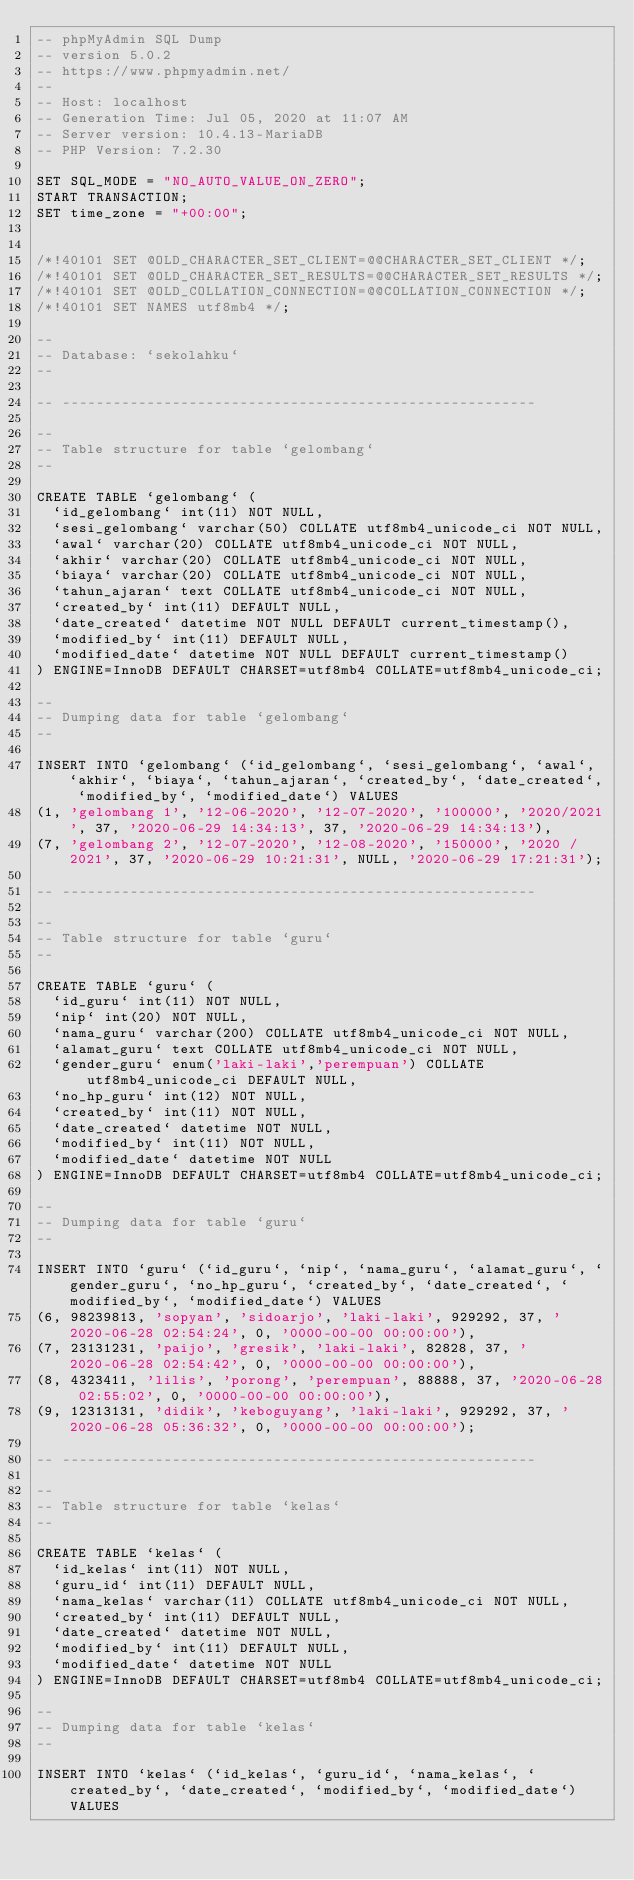Convert code to text. <code><loc_0><loc_0><loc_500><loc_500><_SQL_>-- phpMyAdmin SQL Dump
-- version 5.0.2
-- https://www.phpmyadmin.net/
--
-- Host: localhost
-- Generation Time: Jul 05, 2020 at 11:07 AM
-- Server version: 10.4.13-MariaDB
-- PHP Version: 7.2.30

SET SQL_MODE = "NO_AUTO_VALUE_ON_ZERO";
START TRANSACTION;
SET time_zone = "+00:00";


/*!40101 SET @OLD_CHARACTER_SET_CLIENT=@@CHARACTER_SET_CLIENT */;
/*!40101 SET @OLD_CHARACTER_SET_RESULTS=@@CHARACTER_SET_RESULTS */;
/*!40101 SET @OLD_COLLATION_CONNECTION=@@COLLATION_CONNECTION */;
/*!40101 SET NAMES utf8mb4 */;

--
-- Database: `sekolahku`
--

-- --------------------------------------------------------

--
-- Table structure for table `gelombang`
--

CREATE TABLE `gelombang` (
  `id_gelombang` int(11) NOT NULL,
  `sesi_gelombang` varchar(50) COLLATE utf8mb4_unicode_ci NOT NULL,
  `awal` varchar(20) COLLATE utf8mb4_unicode_ci NOT NULL,
  `akhir` varchar(20) COLLATE utf8mb4_unicode_ci NOT NULL,
  `biaya` varchar(20) COLLATE utf8mb4_unicode_ci NOT NULL,
  `tahun_ajaran` text COLLATE utf8mb4_unicode_ci NOT NULL,
  `created_by` int(11) DEFAULT NULL,
  `date_created` datetime NOT NULL DEFAULT current_timestamp(),
  `modified_by` int(11) DEFAULT NULL,
  `modified_date` datetime NOT NULL DEFAULT current_timestamp()
) ENGINE=InnoDB DEFAULT CHARSET=utf8mb4 COLLATE=utf8mb4_unicode_ci;

--
-- Dumping data for table `gelombang`
--

INSERT INTO `gelombang` (`id_gelombang`, `sesi_gelombang`, `awal`, `akhir`, `biaya`, `tahun_ajaran`, `created_by`, `date_created`, `modified_by`, `modified_date`) VALUES
(1, 'gelombang 1', '12-06-2020', '12-07-2020', '100000', '2020/2021', 37, '2020-06-29 14:34:13', 37, '2020-06-29 14:34:13'),
(7, 'gelombang 2', '12-07-2020', '12-08-2020', '150000', '2020 / 2021', 37, '2020-06-29 10:21:31', NULL, '2020-06-29 17:21:31');

-- --------------------------------------------------------

--
-- Table structure for table `guru`
--

CREATE TABLE `guru` (
  `id_guru` int(11) NOT NULL,
  `nip` int(20) NOT NULL,
  `nama_guru` varchar(200) COLLATE utf8mb4_unicode_ci NOT NULL,
  `alamat_guru` text COLLATE utf8mb4_unicode_ci NOT NULL,
  `gender_guru` enum('laki-laki','perempuan') COLLATE utf8mb4_unicode_ci DEFAULT NULL,
  `no_hp_guru` int(12) NOT NULL,
  `created_by` int(11) NOT NULL,
  `date_created` datetime NOT NULL,
  `modified_by` int(11) NOT NULL,
  `modified_date` datetime NOT NULL
) ENGINE=InnoDB DEFAULT CHARSET=utf8mb4 COLLATE=utf8mb4_unicode_ci;

--
-- Dumping data for table `guru`
--

INSERT INTO `guru` (`id_guru`, `nip`, `nama_guru`, `alamat_guru`, `gender_guru`, `no_hp_guru`, `created_by`, `date_created`, `modified_by`, `modified_date`) VALUES
(6, 98239813, 'sopyan', 'sidoarjo', 'laki-laki', 929292, 37, '2020-06-28 02:54:24', 0, '0000-00-00 00:00:00'),
(7, 23131231, 'paijo', 'gresik', 'laki-laki', 82828, 37, '2020-06-28 02:54:42', 0, '0000-00-00 00:00:00'),
(8, 4323411, 'lilis', 'porong', 'perempuan', 88888, 37, '2020-06-28 02:55:02', 0, '0000-00-00 00:00:00'),
(9, 12313131, 'didik', 'keboguyang', 'laki-laki', 929292, 37, '2020-06-28 05:36:32', 0, '0000-00-00 00:00:00');

-- --------------------------------------------------------

--
-- Table structure for table `kelas`
--

CREATE TABLE `kelas` (
  `id_kelas` int(11) NOT NULL,
  `guru_id` int(11) DEFAULT NULL,
  `nama_kelas` varchar(11) COLLATE utf8mb4_unicode_ci NOT NULL,
  `created_by` int(11) DEFAULT NULL,
  `date_created` datetime NOT NULL,
  `modified_by` int(11) DEFAULT NULL,
  `modified_date` datetime NOT NULL
) ENGINE=InnoDB DEFAULT CHARSET=utf8mb4 COLLATE=utf8mb4_unicode_ci;

--
-- Dumping data for table `kelas`
--

INSERT INTO `kelas` (`id_kelas`, `guru_id`, `nama_kelas`, `created_by`, `date_created`, `modified_by`, `modified_date`) VALUES</code> 